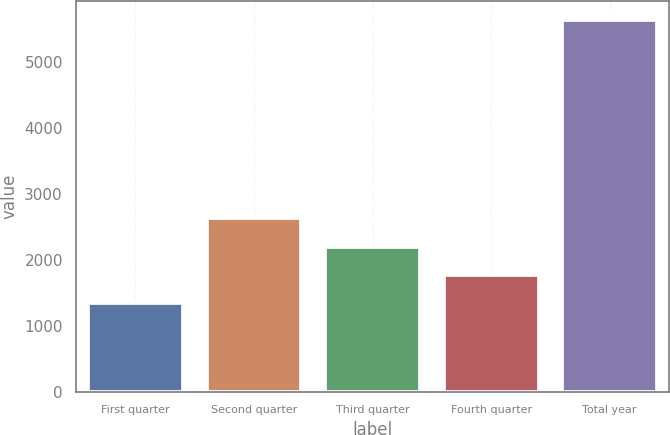<chart> <loc_0><loc_0><loc_500><loc_500><bar_chart><fcel>First quarter<fcel>Second quarter<fcel>Third quarter<fcel>Fourth quarter<fcel>Total year<nl><fcel>1343.6<fcel>2633.21<fcel>2203.34<fcel>1773.47<fcel>5642.3<nl></chart> 